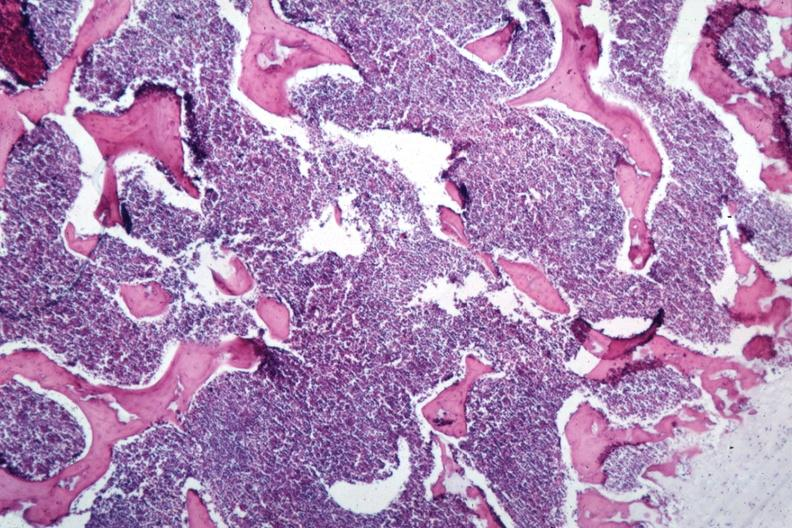what is present?
Answer the question using a single word or phrase. Lymphoblastic lymphoma 